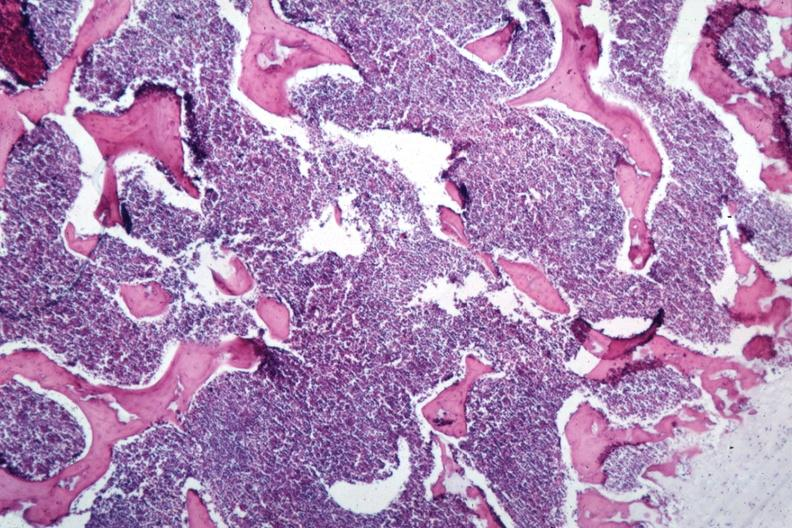what is present?
Answer the question using a single word or phrase. Lymphoblastic lymphoma 